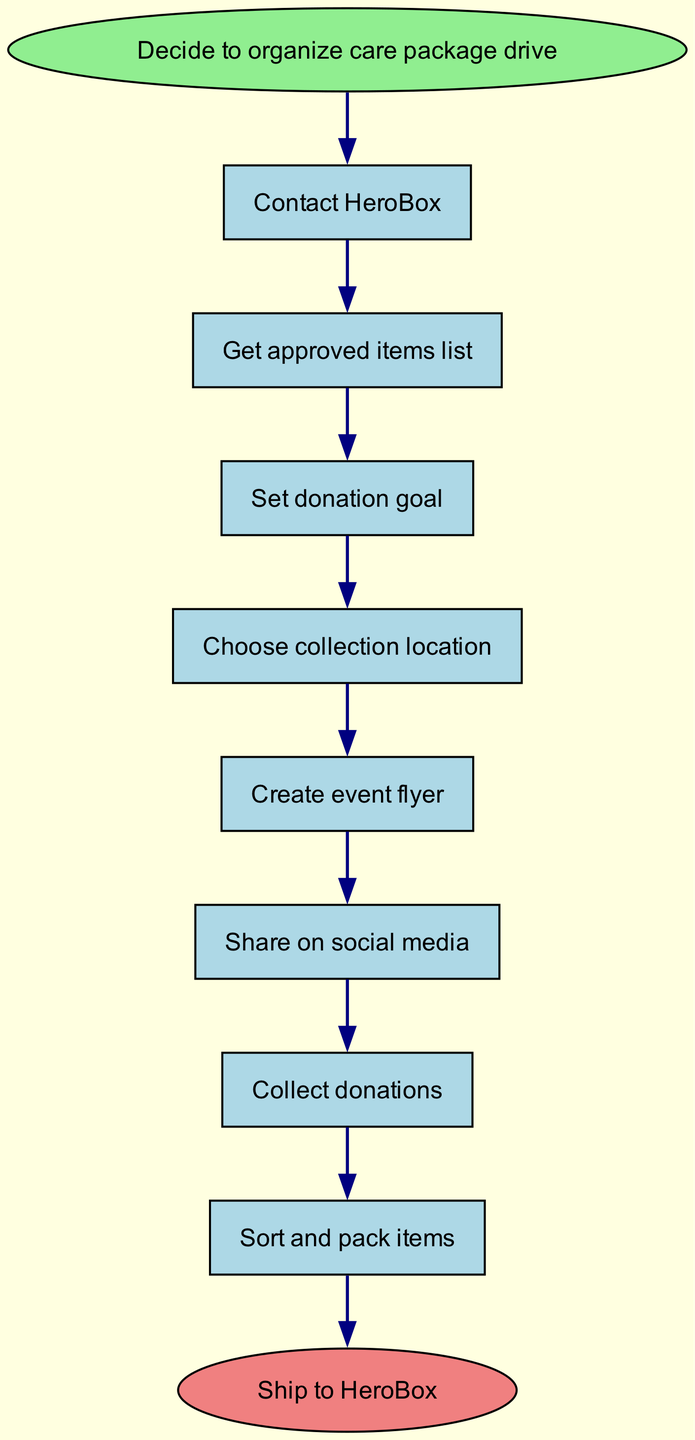What is the first step in the care package donation drive? The first step is labeled as "Decide to organize care package drive," which is indicated in the start node.
Answer: Decide to organize care package drive How many steps are there in the process? By counting the individual steps listed in the flow chart, we find there are 8 defined steps.
Answer: 8 What is the last step before shipping the items? The last step prior to shipping is indicated as "Sort and pack items," which is the second to last node directly connected before the final shipping node.
Answer: Sort and pack items What follows after sharing on social media? The step that follows "Share on social media" is labeled as "Collect donations," which is the next node directly connected to the sharing node.
Answer: Collect donations Which step requires setting a donation goal? The step that specifically includes setting a donation goal is indicated as "Set donation goal," which comes after obtaining the approved item list.
Answer: Set donation goal What does the end node represent in the flow chart? The end node is labeled "Ship to HeroBox," indicating the final action to be taken once all previous steps have been completed.
Answer: Ship to HeroBox Which step directly follows contacting HeroBox? After the "Contact HeroBox" step, the next action is obtaining the "Get approved items list," which is the next connected node in the sequence.
Answer: Get approved items list What is the third step in organizing the care package donation drive? The third step is "Set donation goal," which comes after "Get approved items list" and prior to "Choose collection location."
Answer: Set donation goal 